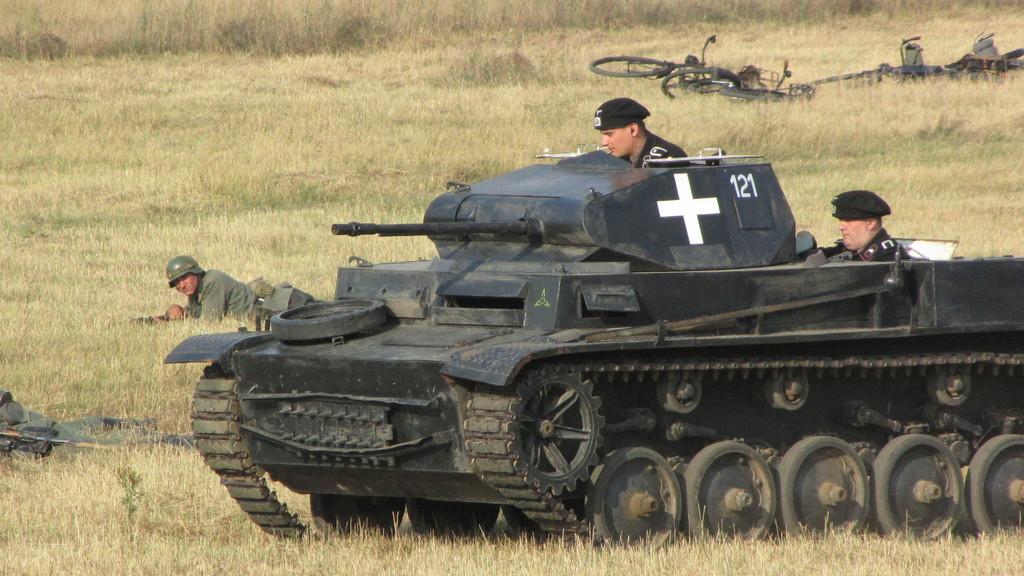How would you summarize this image in a sentence or two? In this image in the center there is a military tank and there are persons on the tank. In the background there are persons lying on the ground and there are objects which are black in colour and there is dry grass on the ground. 